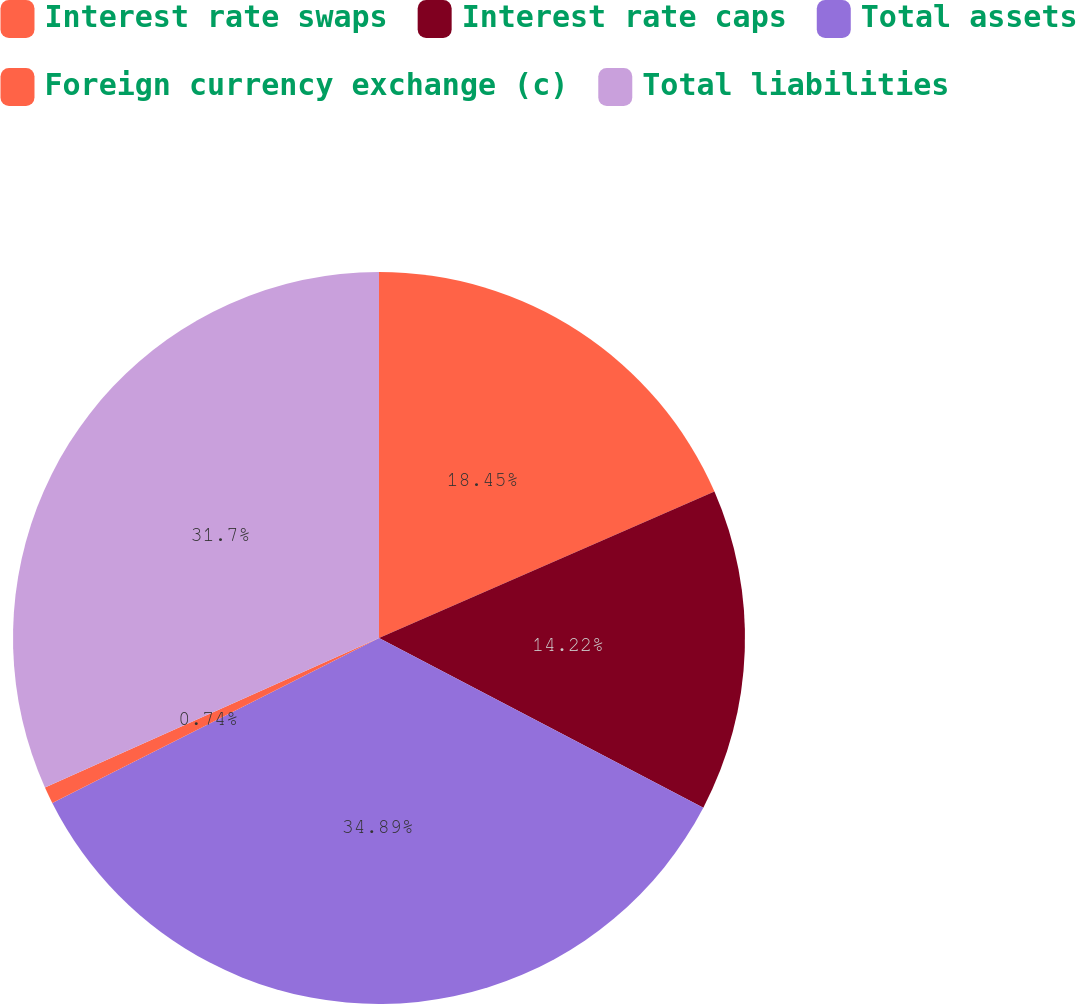Convert chart. <chart><loc_0><loc_0><loc_500><loc_500><pie_chart><fcel>Interest rate swaps<fcel>Interest rate caps<fcel>Total assets<fcel>Foreign currency exchange (c)<fcel>Total liabilities<nl><fcel>18.45%<fcel>14.22%<fcel>34.89%<fcel>0.74%<fcel>31.7%<nl></chart> 